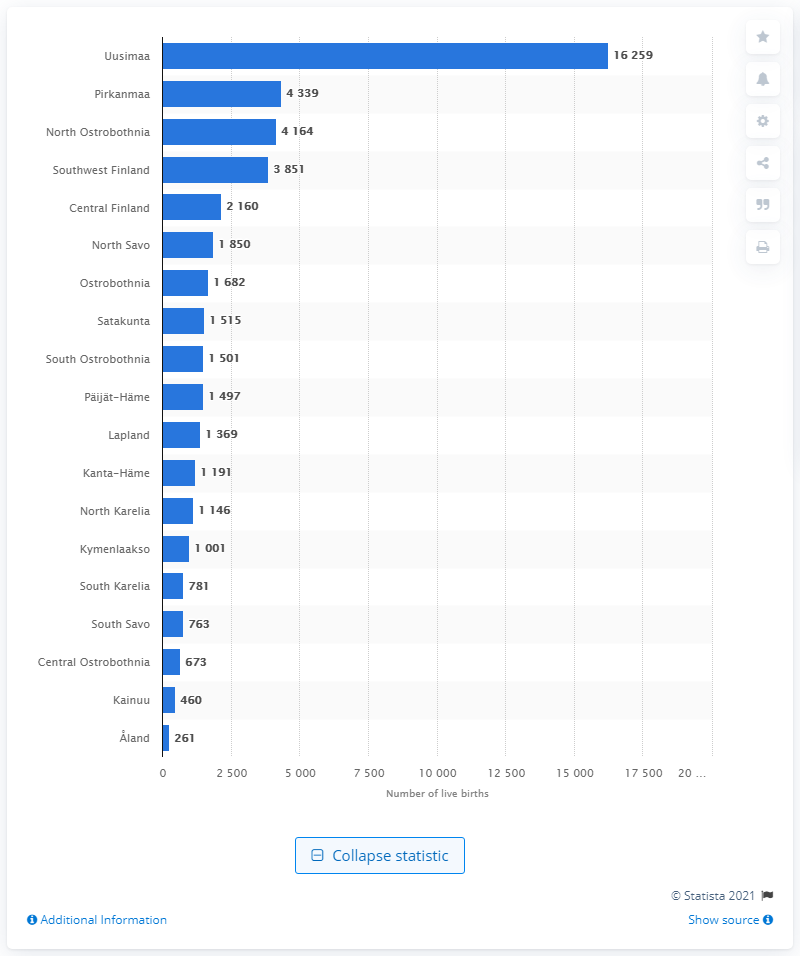Mention a couple of crucial points in this snapshot. In 2020, a total of 261 children were born in the...land. In 2020, Uusimaa was the region in Finland where the highest number of children were born. 